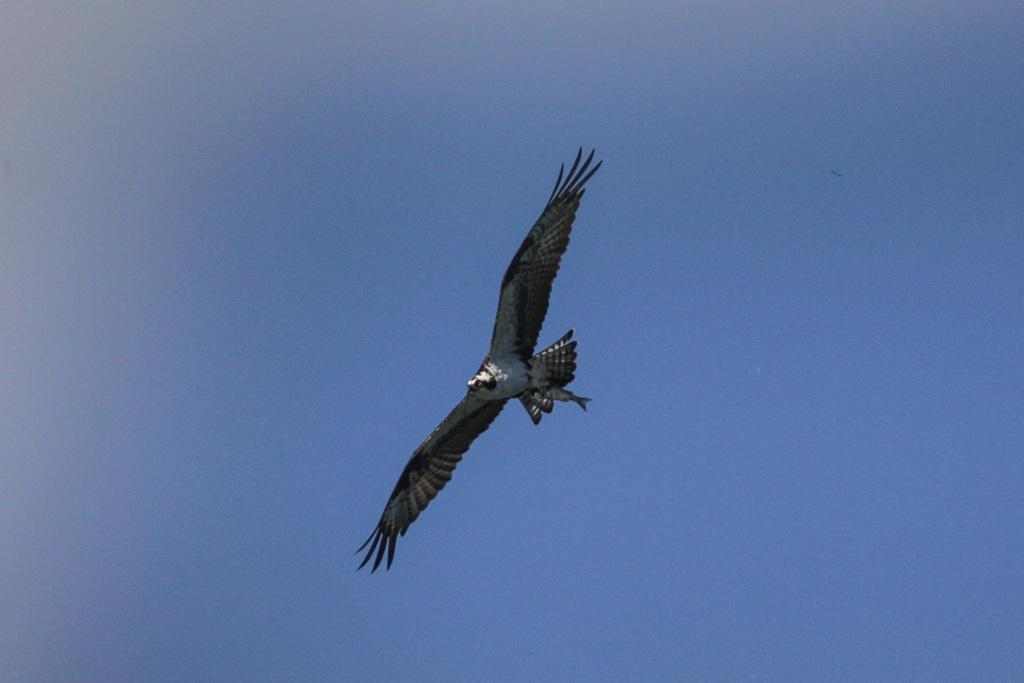What animal is present in the image? There is an eagle in the image. What is the eagle doing in the image? The eagle is flying in the image. What can be seen in the background of the image? There is a sky visible in the image. Where is the kitten playing near the lake in the image? There is no kitten or lake present in the image; it features an eagle flying in the sky. How many clocks can be seen in the image? There are no clocks visible in the image. 